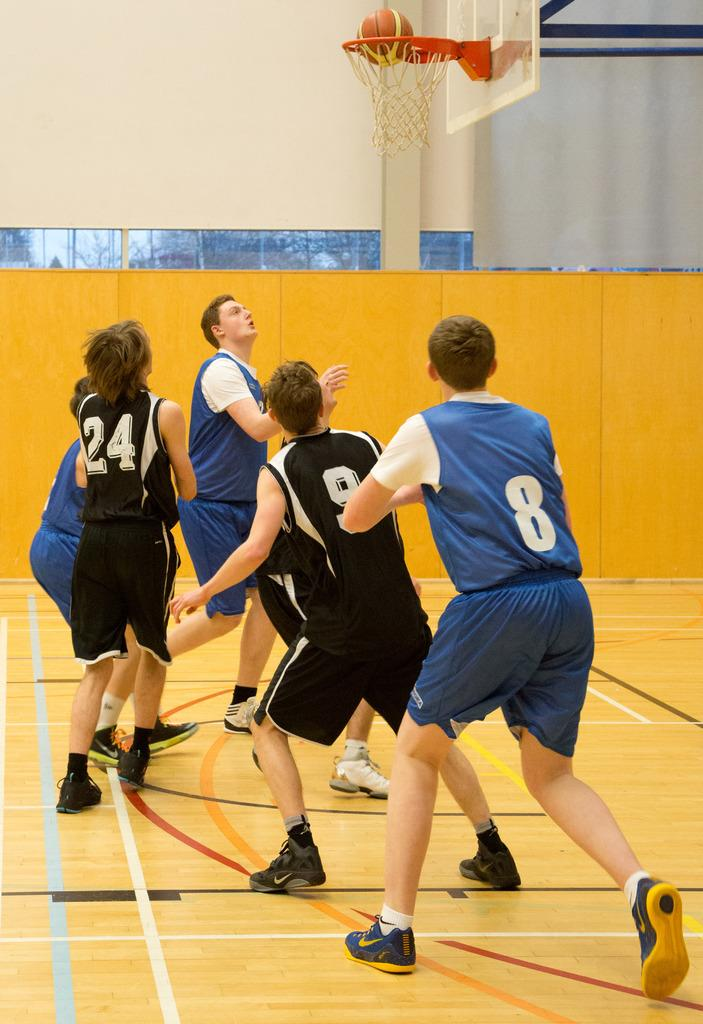How many people are in the image? There is a group of people in the image. What are the people doing in the image? The people are on the ground. What object is present in the image that is typically used in sports? There is a goal post in the image. What object is present in the image that is used to play the game? There is a ball in the image. What is the purpose of the banner in the image? The banner in the image is likely used for identification or support. What type of structure can be seen in the background of the image? There is a wall in the image. What type of fog can be seen in the image? There is no fog present in the image. How does the brother participate in the game in the image? There is no mention of a brother or any specific individuals in the image, so it cannot be determined how they might participate in the game. 